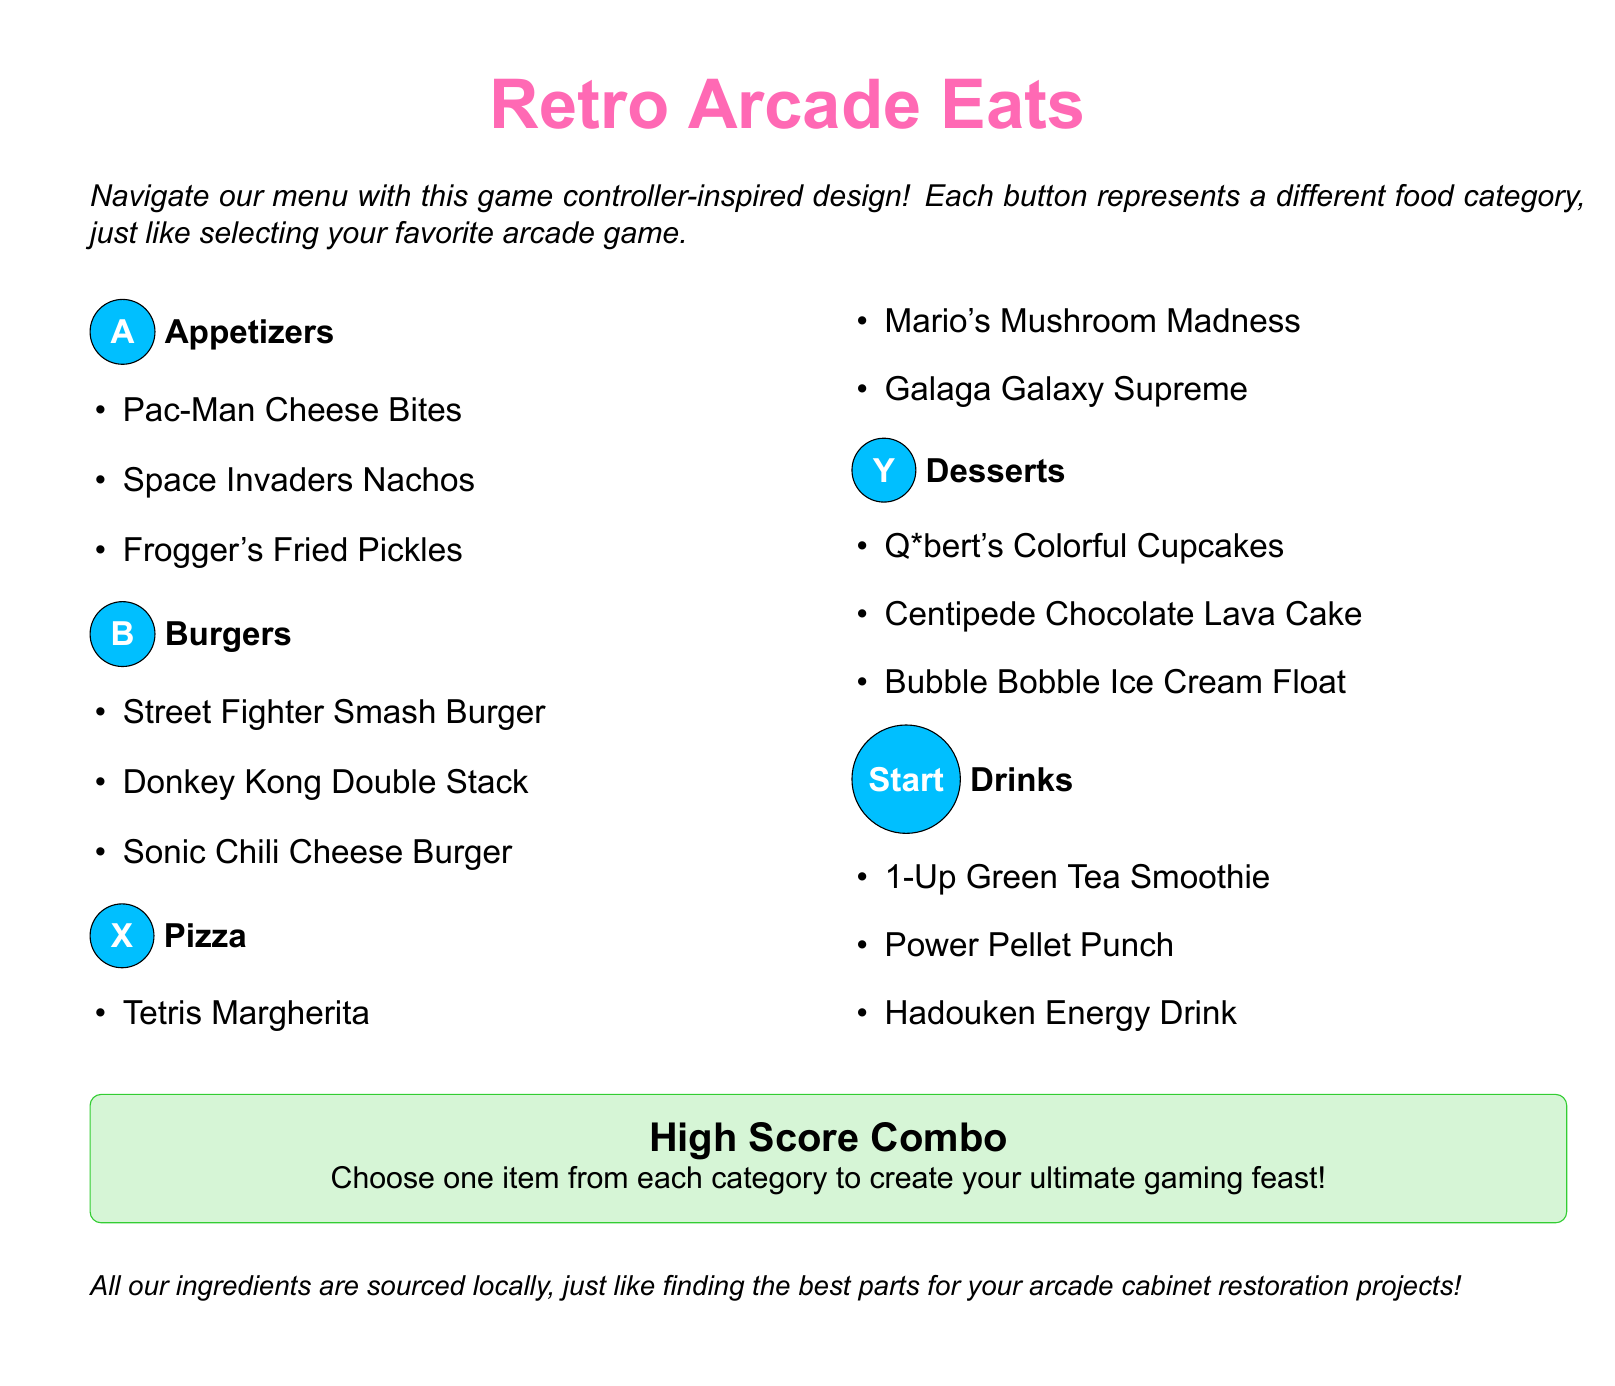What is the title of the menu? The title is prominently displayed at the top of the document in a large font.
Answer: Retro Arcade Eats How many categories are there in the menu? The menu has a game-controller inspired design with five different food categories.
Answer: Five What item is listed under the Appetizers category? The document provides a list of specific items under each category.
Answer: Pac-Man Cheese Bites What is the name of a drink available on the menu? The drink options are provided in the Drinks section of the menu.
Answer: 1-Up Green Tea Smoothie What dessert is associated with Q*bert? The dessert options are creatively linked to arcade games and characters.
Answer: Q*bert's Colorful Cupcakes What does the "High Score Combo" offer? The document describes a special option to combine items from different categories.
Answer: Choose one item from each category Which color represents the Drinks category? The document utilizes different colors to enhance visual appeal and categorize sections.
Answer: Arcadegreen Name a burger on the menu with a character from a game. The menu includes burgers named after popular video game characters.
Answer: Street Fighter Smash Burger What does the menu say about ingredient sourcing? There is a note regarding ingredient sourcing as it relates to arcade cabinet restoration projects.
Answer: Sourced locally 